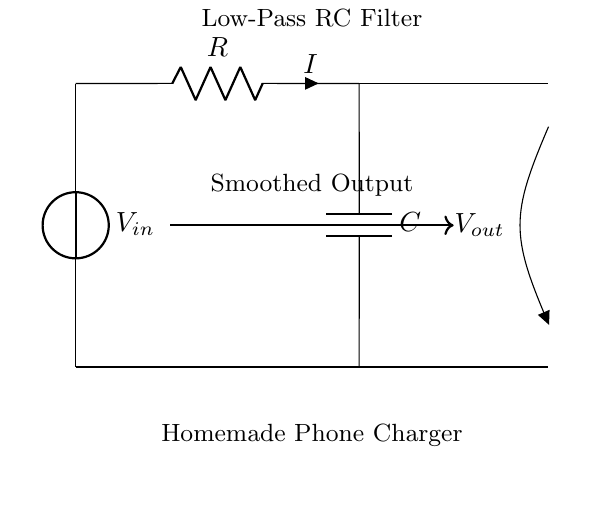What is the input voltage of this circuit? The input voltage, labeled as Vin, is provided by the voltage source at the top left of the diagram.
Answer: Vin What is the component labeled R? The component labeled R is a resistor, which can be identified by its symbol in the circuit.
Answer: Resistor What type of filter is this circuit designed for? This circuit is designed as a low-pass filter, as indicated by the arrangement of the resistor and capacitor.
Answer: Low-pass filter What is the purpose of the capacitor in this circuit? The purpose of the capacitor is to smooth out fluctuations in the voltage, allowing only low-frequency signals to pass through.
Answer: Smoothing How does the output voltage relate to the input voltage? The output voltage, labeled as Vout, is the voltage measured across the capacitor, which is lower than the input voltage due to the filter action of the RC circuit.
Answer: Lower What happens to high-frequency signals in this circuit? High-frequency signals are attenuated by the RC filter, meaning they are reduced in magnitude and do not appear at the output.
Answer: Attenuated 